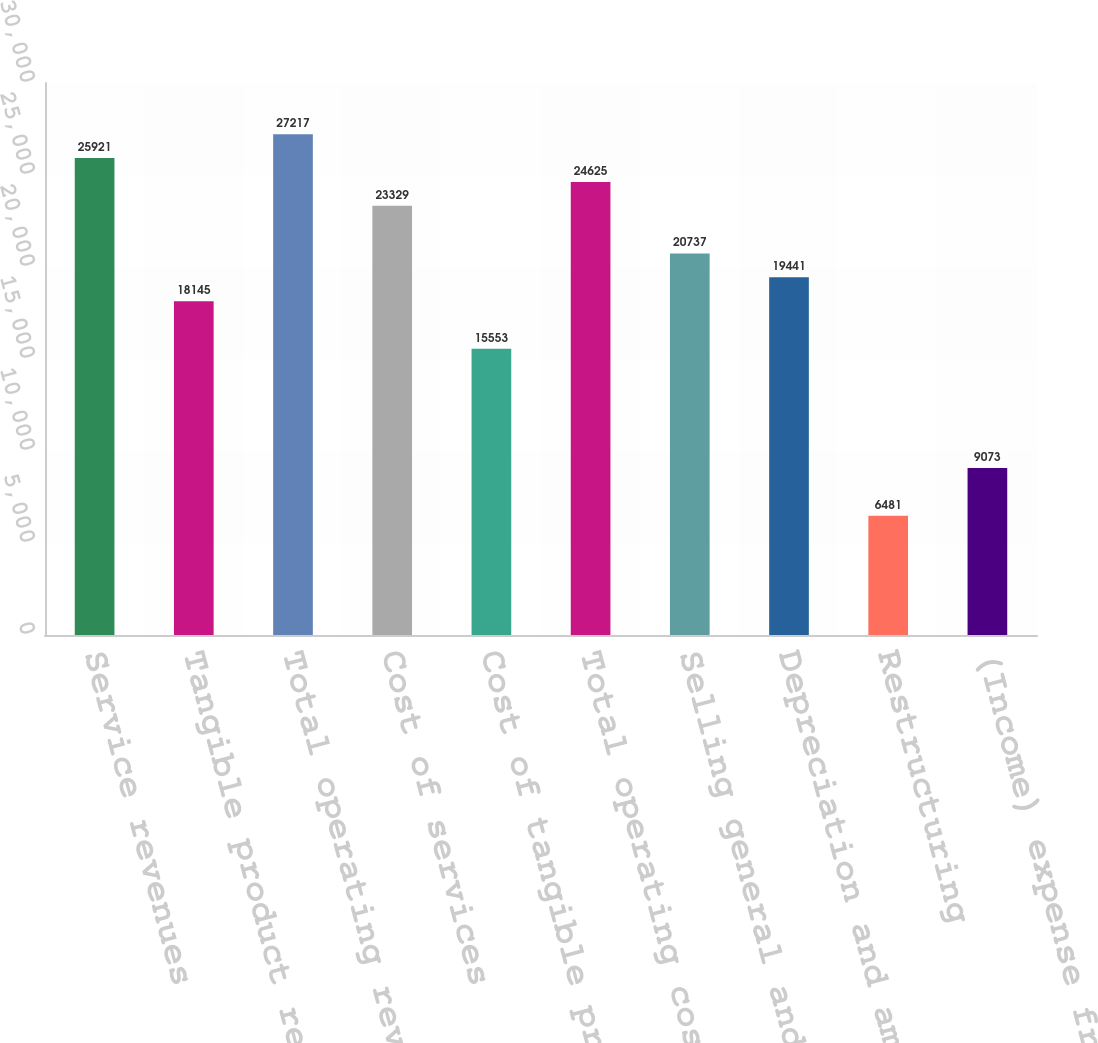Convert chart. <chart><loc_0><loc_0><loc_500><loc_500><bar_chart><fcel>Service revenues<fcel>Tangible product revenues<fcel>Total operating revenues<fcel>Cost of services<fcel>Cost of tangible products<fcel>Total operating costs<fcel>Selling general and<fcel>Depreciation and amortization<fcel>Restructuring<fcel>(Income) expense from<nl><fcel>25921<fcel>18145<fcel>27217<fcel>23329<fcel>15553<fcel>24625<fcel>20737<fcel>19441<fcel>6481<fcel>9073<nl></chart> 